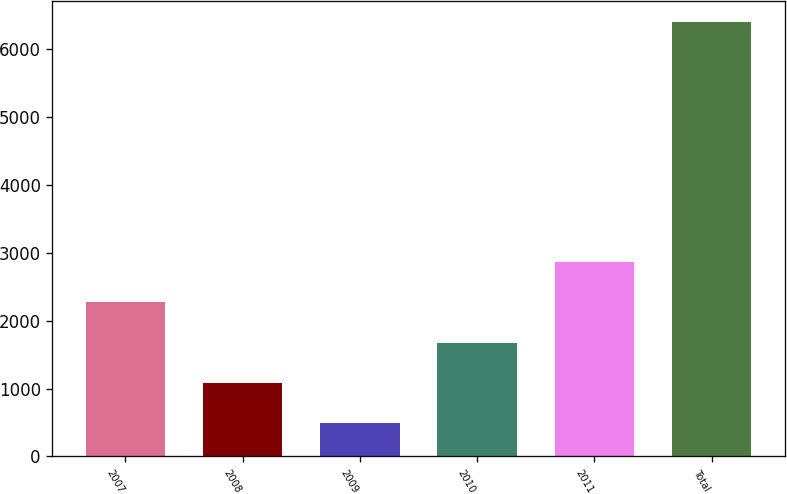<chart> <loc_0><loc_0><loc_500><loc_500><bar_chart><fcel>2007<fcel>2008<fcel>2009<fcel>2010<fcel>2011<fcel>Total<nl><fcel>2269.6<fcel>1089.2<fcel>499<fcel>1679.4<fcel>2859.8<fcel>6401<nl></chart> 